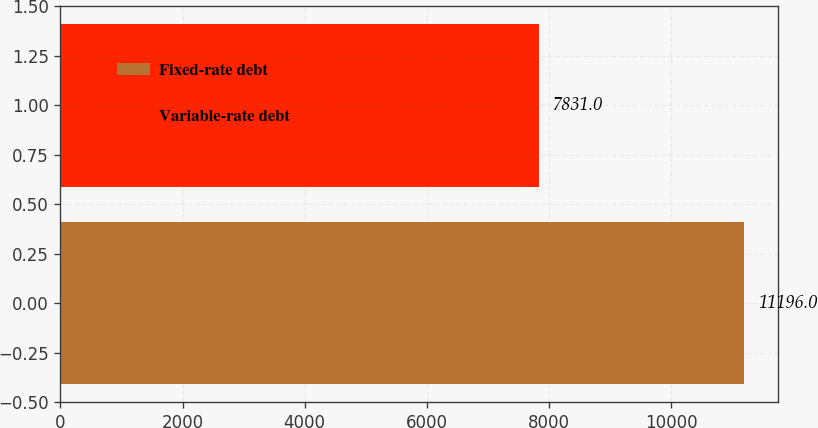Convert chart to OTSL. <chart><loc_0><loc_0><loc_500><loc_500><bar_chart><fcel>Fixed-rate debt<fcel>Variable-rate debt<nl><fcel>11196<fcel>7831<nl></chart> 